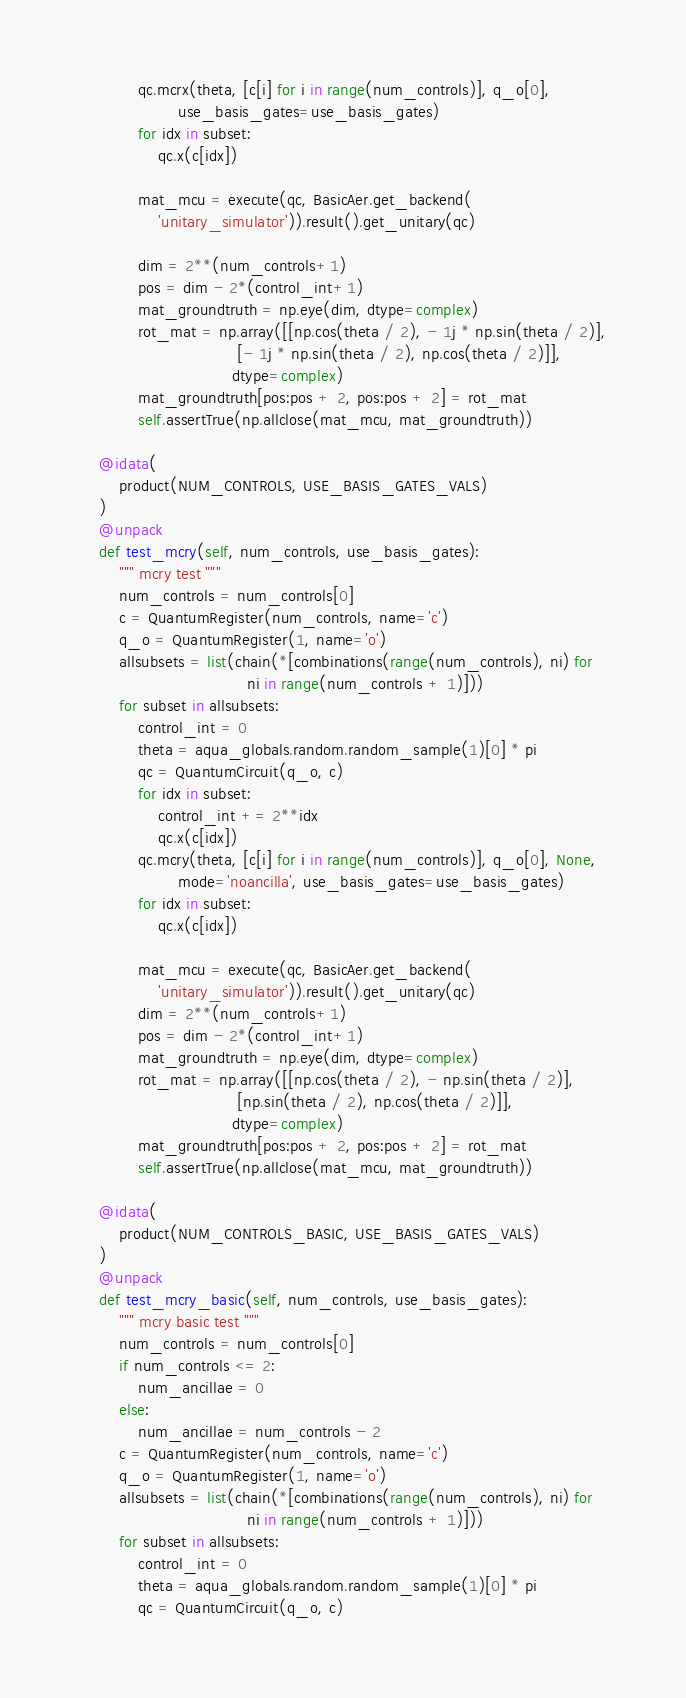<code> <loc_0><loc_0><loc_500><loc_500><_Python_>            qc.mcrx(theta, [c[i] for i in range(num_controls)], q_o[0],
                    use_basis_gates=use_basis_gates)
            for idx in subset:
                qc.x(c[idx])

            mat_mcu = execute(qc, BasicAer.get_backend(
                'unitary_simulator')).result().get_unitary(qc)

            dim = 2**(num_controls+1)
            pos = dim - 2*(control_int+1)
            mat_groundtruth = np.eye(dim, dtype=complex)
            rot_mat = np.array([[np.cos(theta / 2), - 1j * np.sin(theta / 2)],
                                [- 1j * np.sin(theta / 2), np.cos(theta / 2)]],
                               dtype=complex)
            mat_groundtruth[pos:pos + 2, pos:pos + 2] = rot_mat
            self.assertTrue(np.allclose(mat_mcu, mat_groundtruth))

    @idata(
        product(NUM_CONTROLS, USE_BASIS_GATES_VALS)
    )
    @unpack
    def test_mcry(self, num_controls, use_basis_gates):
        """ mcry test """
        num_controls = num_controls[0]
        c = QuantumRegister(num_controls, name='c')
        q_o = QuantumRegister(1, name='o')
        allsubsets = list(chain(*[combinations(range(num_controls), ni) for
                                  ni in range(num_controls + 1)]))
        for subset in allsubsets:
            control_int = 0
            theta = aqua_globals.random.random_sample(1)[0] * pi
            qc = QuantumCircuit(q_o, c)
            for idx in subset:
                control_int += 2**idx
                qc.x(c[idx])
            qc.mcry(theta, [c[i] for i in range(num_controls)], q_o[0], None,
                    mode='noancilla', use_basis_gates=use_basis_gates)
            for idx in subset:
                qc.x(c[idx])

            mat_mcu = execute(qc, BasicAer.get_backend(
                'unitary_simulator')).result().get_unitary(qc)
            dim = 2**(num_controls+1)
            pos = dim - 2*(control_int+1)
            mat_groundtruth = np.eye(dim, dtype=complex)
            rot_mat = np.array([[np.cos(theta / 2), - np.sin(theta / 2)],
                                [np.sin(theta / 2), np.cos(theta / 2)]],
                               dtype=complex)
            mat_groundtruth[pos:pos + 2, pos:pos + 2] = rot_mat
            self.assertTrue(np.allclose(mat_mcu, mat_groundtruth))

    @idata(
        product(NUM_CONTROLS_BASIC, USE_BASIS_GATES_VALS)
    )
    @unpack
    def test_mcry_basic(self, num_controls, use_basis_gates):
        """ mcry basic test """
        num_controls = num_controls[0]
        if num_controls <= 2:
            num_ancillae = 0
        else:
            num_ancillae = num_controls - 2
        c = QuantumRegister(num_controls, name='c')
        q_o = QuantumRegister(1, name='o')
        allsubsets = list(chain(*[combinations(range(num_controls), ni) for
                                  ni in range(num_controls + 1)]))
        for subset in allsubsets:
            control_int = 0
            theta = aqua_globals.random.random_sample(1)[0] * pi
            qc = QuantumCircuit(q_o, c)</code> 